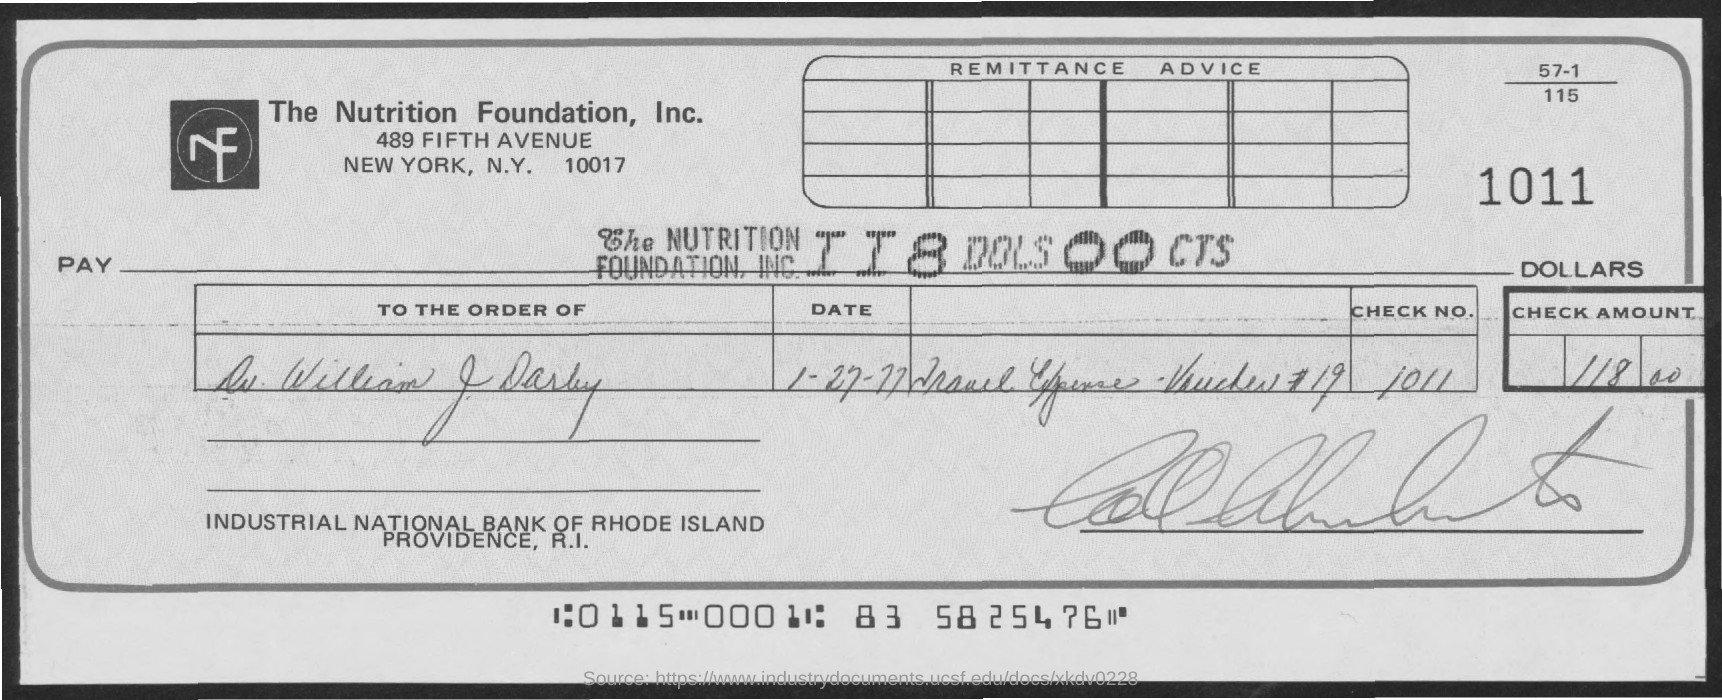Mention a couple of crucial points in this snapshot. The cheque is paid to the order of Dr. William J. Darby. The full-form of NF is Nutrition Foundation. The cheque is for the amount of $118.00. 